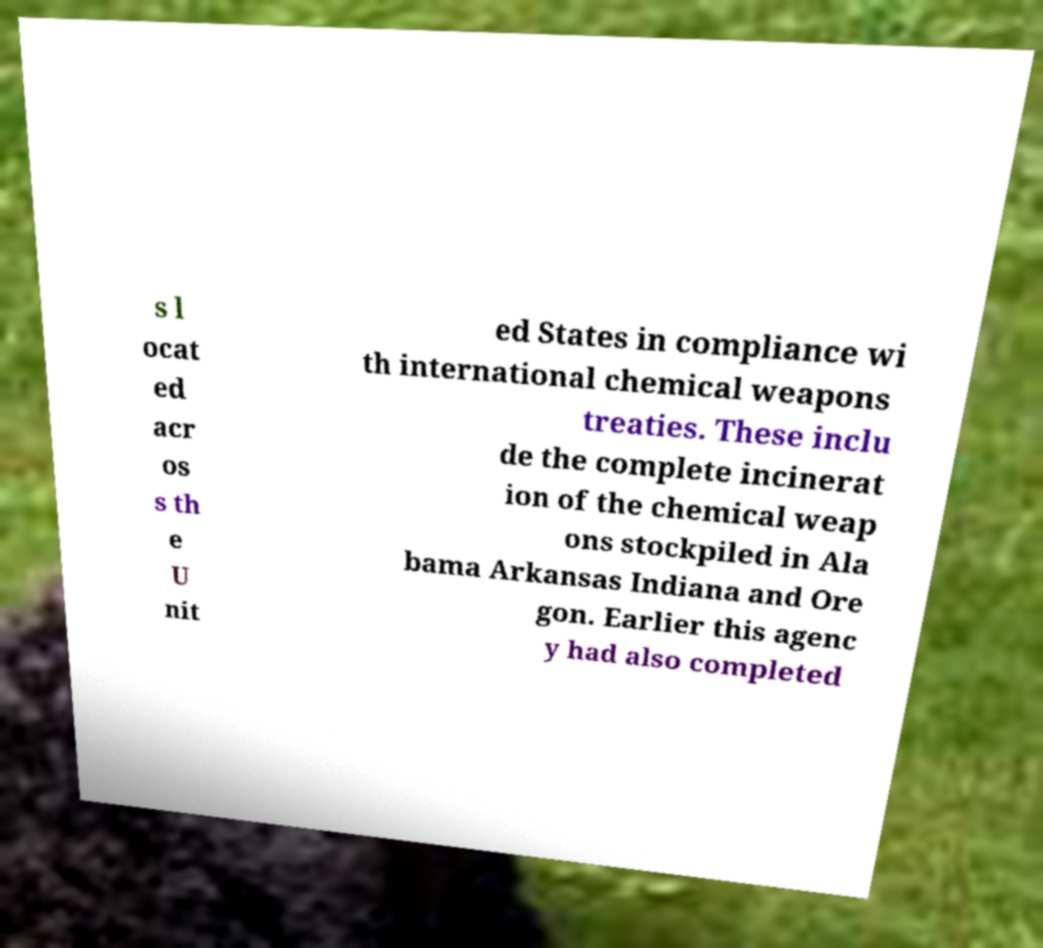Please read and relay the text visible in this image. What does it say? s l ocat ed acr os s th e U nit ed States in compliance wi th international chemical weapons treaties. These inclu de the complete incinerat ion of the chemical weap ons stockpiled in Ala bama Arkansas Indiana and Ore gon. Earlier this agenc y had also completed 